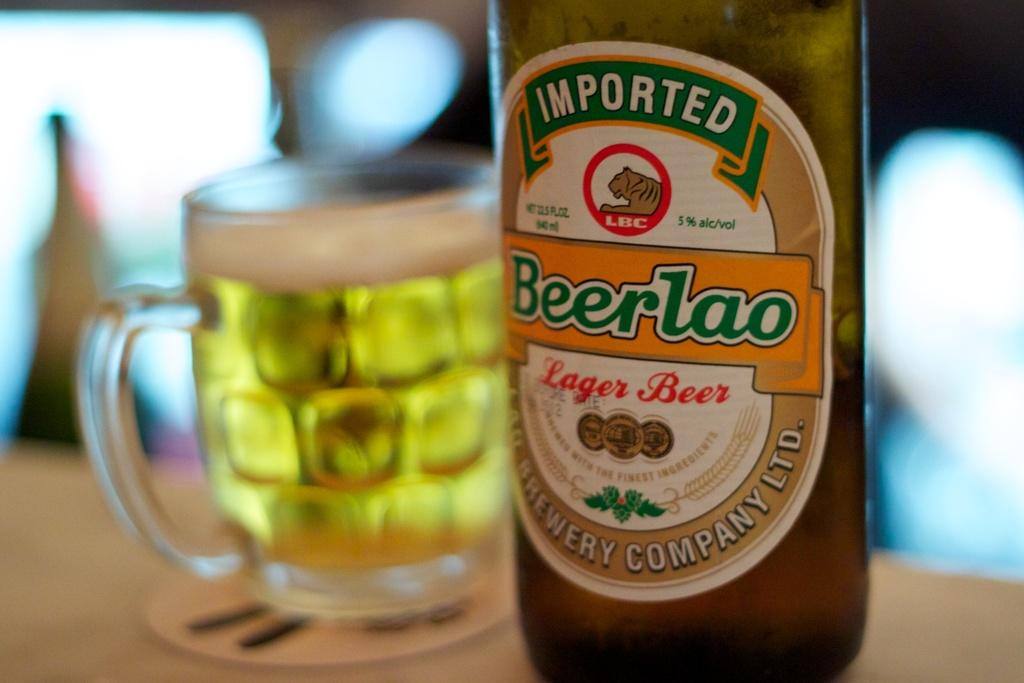<image>
Create a compact narrative representing the image presented. A bottle of Imported Beerlao beer in front of a cup of beer. 